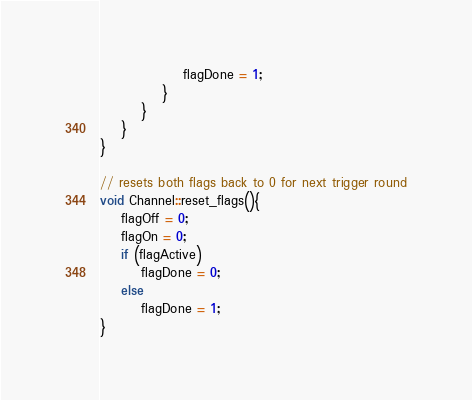Convert code to text. <code><loc_0><loc_0><loc_500><loc_500><_C++_>				flagDone = 1;
			}
		}
	}
}

// resets both flags back to 0 for next trigger round
void Channel::reset_flags(){
	flagOff = 0;
	flagOn = 0;
	if (flagActive)
		flagDone = 0;
	else
		flagDone = 1;
}
</code> 